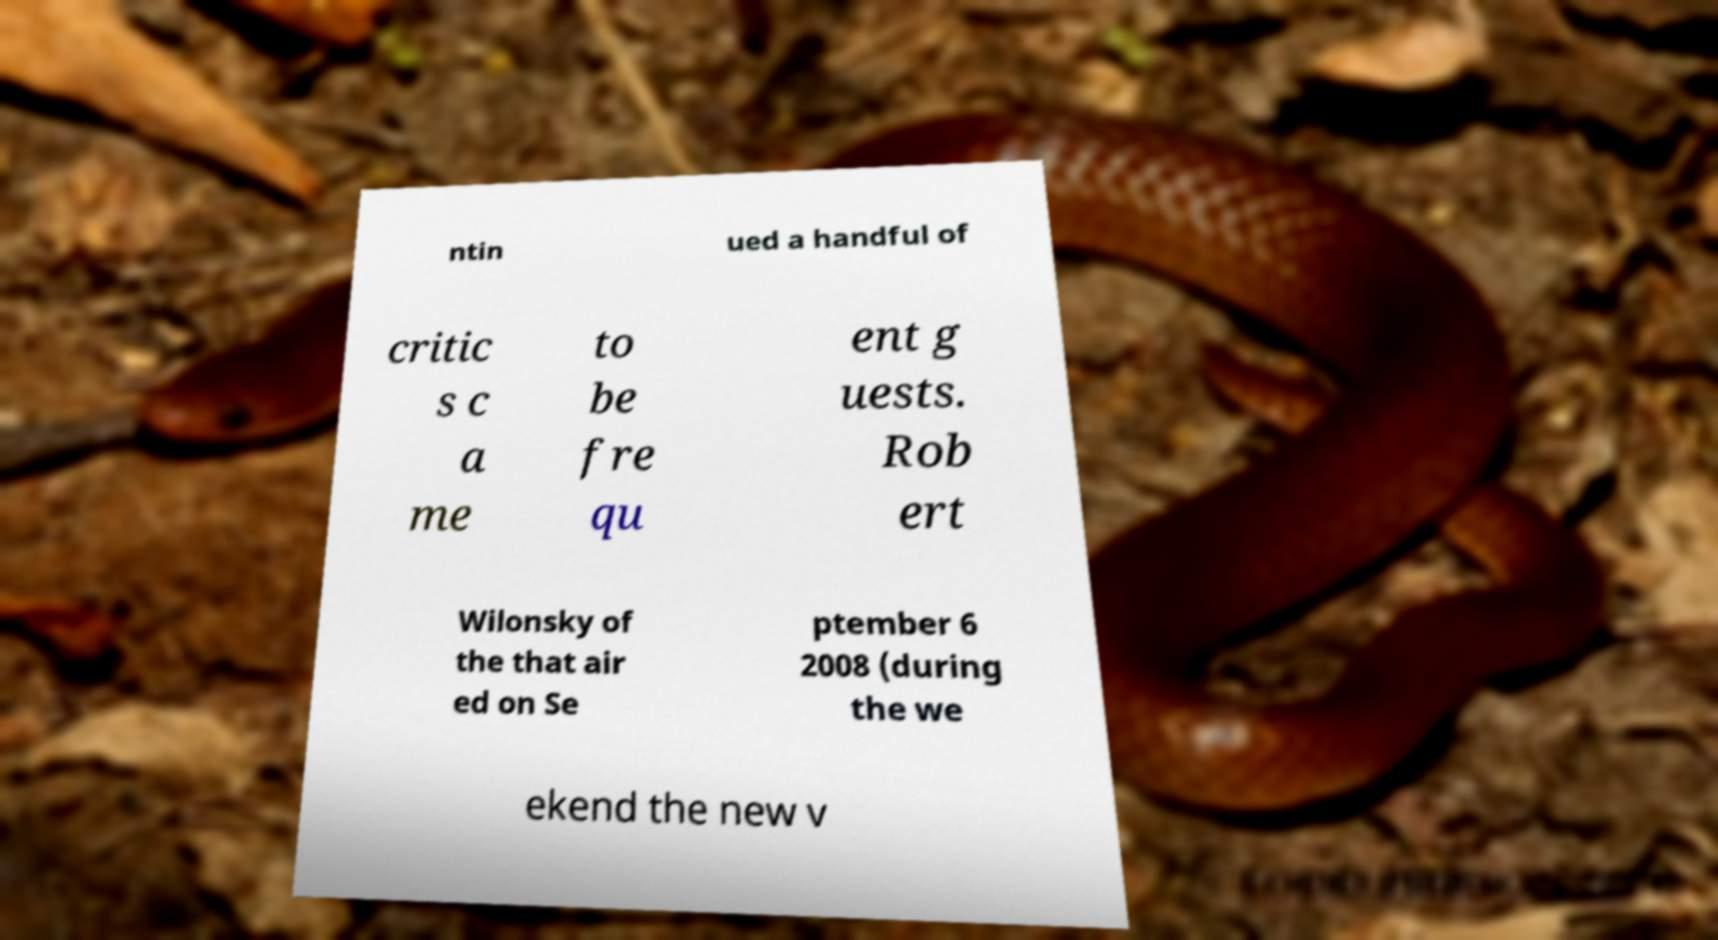There's text embedded in this image that I need extracted. Can you transcribe it verbatim? ntin ued a handful of critic s c a me to be fre qu ent g uests. Rob ert Wilonsky of the that air ed on Se ptember 6 2008 (during the we ekend the new v 